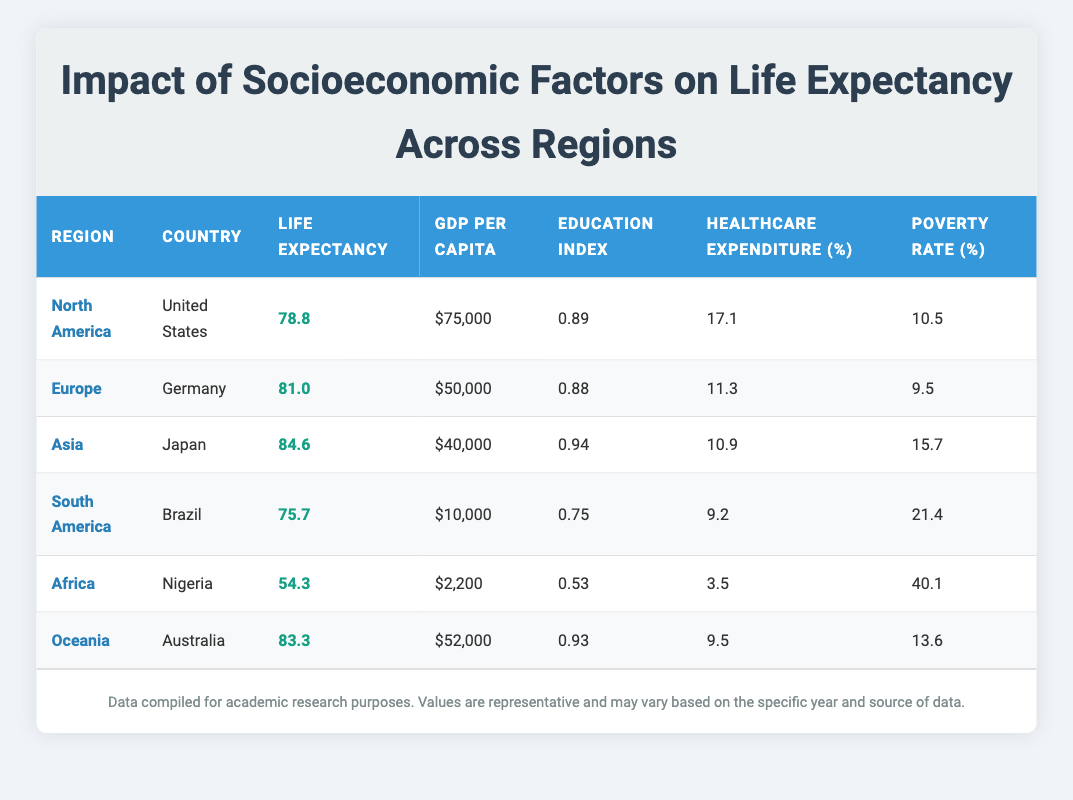What is the life expectancy of Japan? The life expectancy entry for Japan in the table shows a value of 84.6 years.
Answer: 84.6 Which country has the highest GDP per capita? From the data, the United States has a GDP per capita of $75,000, which is the highest among all the countries listed.
Answer: United States Is the poverty rate in Nigeria higher than that in Brazil? The poverty rate for Nigeria is 40.1%, while Brazil's poverty rate is 21.4%. Since 40.1% is greater than 21.4%, the statement is true.
Answer: Yes What is the average life expectancy of countries in Oceania? There is only one entry for Oceania (Australia) with a life expectancy of 83.3 years, so the average is simply 83.3 years.
Answer: 83.3 What is the difference in life expectancy between the United States and Germany? The life expectancy of the United States is 78.8 years, and that of Germany is 81.0 years. To find the difference, subtract the US figure from Germany's: 81.0 - 78.8 = 2.2 years.
Answer: 2.2 Which region has the lowest healthcare expenditure percentage? The table shows Nigeria, under the Africa region, with a healthcare expenditure of 3.5%, which is lower than all other entries.
Answer: Africa Are the education indices for Germany and Australia equal? Germany has an education index of 0.88, while Australia has an education index of 0.93. Since these figures are not the same, the answer is no.
Answer: No What is the combined GDP per capita of Japan and Brazil? Japan's GDP per capita is $40,000 and Brazil's is $10,000. Adding these together: 40,000 + 10,000 = 50,000.
Answer: $50,000 Which country has the highest life expectancy and what is the value? Japan has the highest life expectancy at 84.6 years when compared to all other listed countries.
Answer: Japan, 84.6 